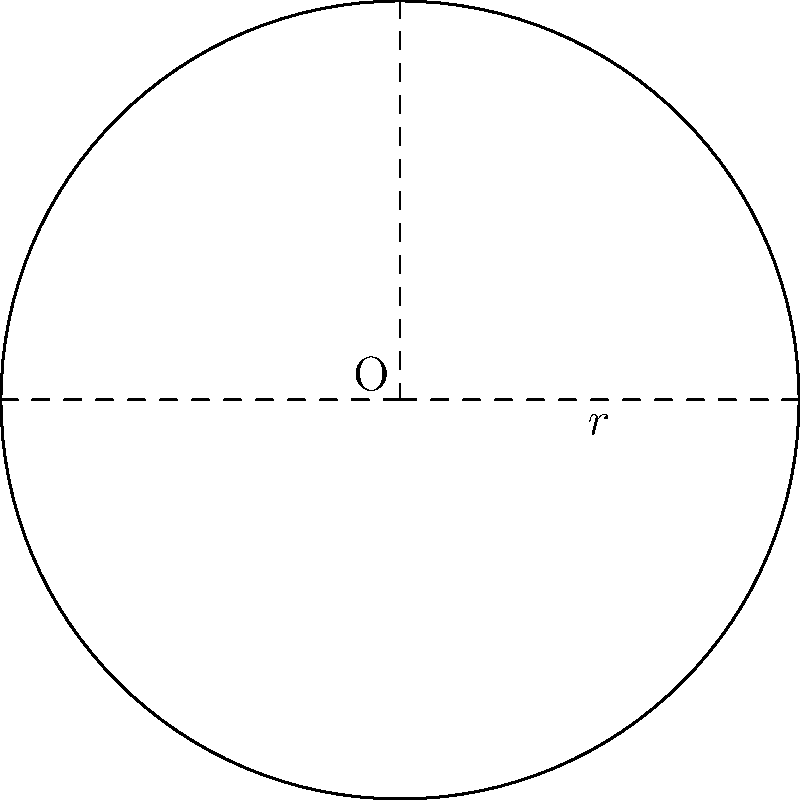In a traditional Japanese garden, there is a circular pond with a radius of 3 meters. The landscape architect wants to create a walking path around the pond that is 1 meter wide. What is the difference between the area of the walking path and the area of the pond? Let's approach this step-by-step:

1) First, we need to calculate the area of the pond:
   Area of pond = $\pi r^2 = \pi \cdot 3^2 = 9\pi$ square meters

2) Next, we need to calculate the area of the larger circle that includes both the pond and the walking path:
   Radius of larger circle = 3 + 1 = 4 meters
   Area of larger circle = $\pi r^2 = \pi \cdot 4^2 = 16\pi$ square meters

3) The area of the walking path is the difference between these two areas:
   Area of path = Area of larger circle - Area of pond
                = $16\pi - 9\pi = 7\pi$ square meters

4) The question asks for the difference between the area of the walking path and the area of the pond:
   Difference = Area of path - Area of pond
              = $7\pi - 9\pi = -2\pi$ square meters

The negative sign indicates that the pond's area is larger than the path's area.
Answer: $-2\pi$ square meters 